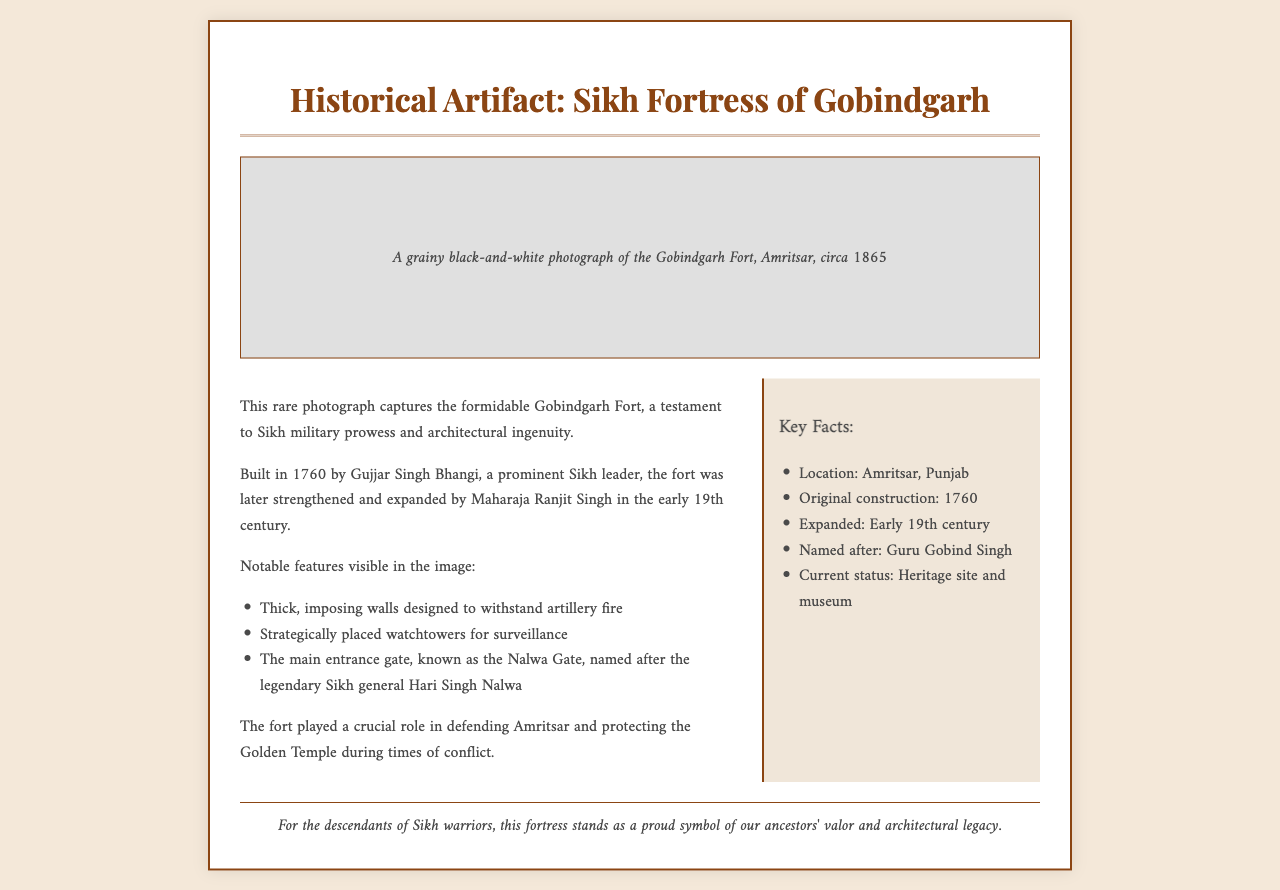What is the title of the document? The title is presented prominently at the top of the fax.
Answer: Historical Artifact: Sikh Fortress of Gobindgarh What year was the photograph taken? The document specifies the date around which the photograph was captured.
Answer: circa 1865 Who built the Gobindgarh Fort? The text mentions the prominent Sikh leader responsible for the fort's original construction.
Answer: Gujjar Singh Bhangi What significant feature is named after a Sikh general? The document indicates a particular gate known for its historical significance.
Answer: Nalwa Gate What is the location of the Gobindgarh Fort? The key facts section provides the specific region where the fort is situated.
Answer: Amritsar, Punjab What is the current status of the fort? The document mentions what the fortress is recognized as today.
Answer: Heritage site and museum What architectural feature was designed to withstand artillery fire? The details point out the fort's defensive design features.
Answer: Thick, imposing walls In which century was the fort expanded? The document specifies the time period when significant expansions occurred.
Answer: Early 19th century 